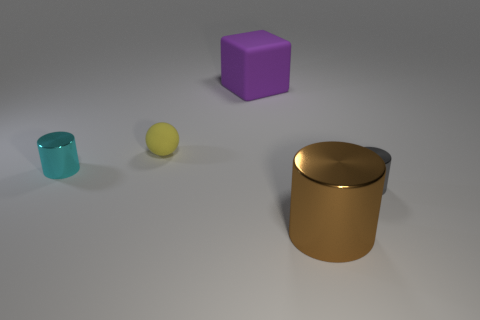What is the material of the small ball left of the purple rubber cube?
Ensure brevity in your answer.  Rubber. Do the tiny thing on the right side of the yellow rubber ball and the cylinder left of the purple matte cube have the same material?
Provide a short and direct response. Yes. Is the number of tiny cylinders that are right of the small yellow sphere the same as the number of purple rubber things behind the brown metallic cylinder?
Your answer should be compact. Yes. How many tiny objects are the same material as the big cylinder?
Provide a succinct answer. 2. What is the size of the thing behind the matte object in front of the big purple object?
Your answer should be compact. Large. Is the shape of the tiny cyan metallic thing in front of the small yellow ball the same as the matte thing that is left of the big matte object?
Give a very brief answer. No. Is the number of matte objects that are behind the cyan cylinder the same as the number of tiny rubber spheres?
Your answer should be very brief. No. What is the color of the large metallic object that is the same shape as the small gray thing?
Your answer should be compact. Brown. Is the small cylinder on the right side of the yellow rubber ball made of the same material as the large brown cylinder?
Ensure brevity in your answer.  Yes. What number of tiny things are either blue metal objects or cylinders?
Provide a short and direct response. 2. 